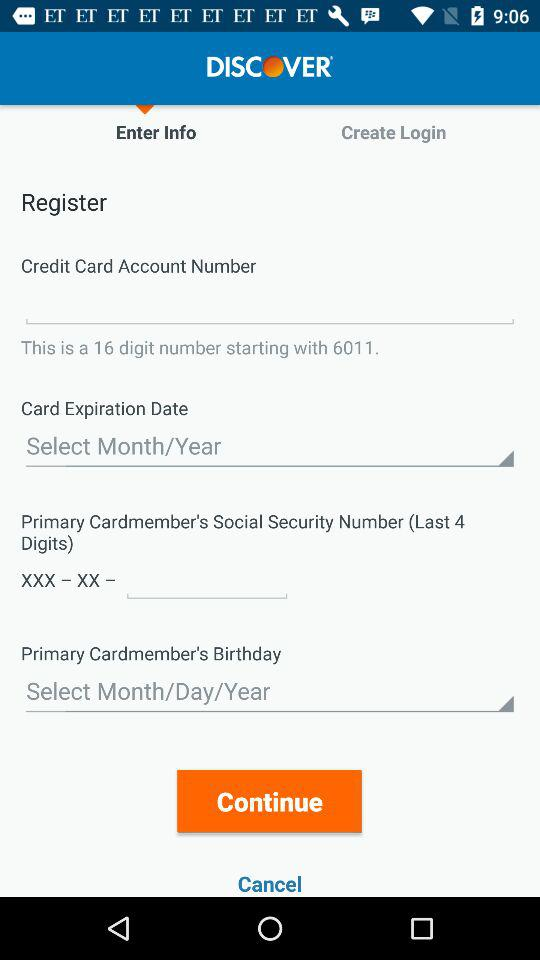How many text inputs are required for the credit card registration?
Answer the question using a single word or phrase. 4 